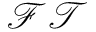Convert formula to latex. <formula><loc_0><loc_0><loc_500><loc_500>\mathcal { F T }</formula> 